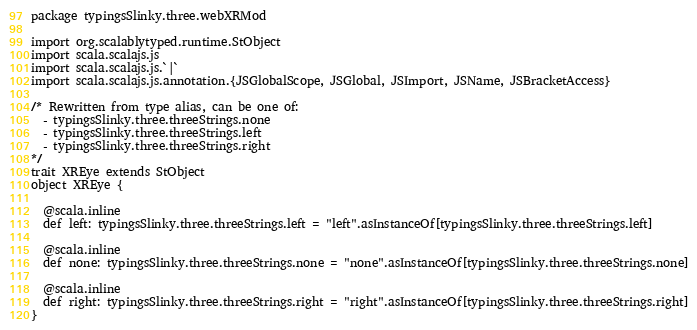Convert code to text. <code><loc_0><loc_0><loc_500><loc_500><_Scala_>package typingsSlinky.three.webXRMod

import org.scalablytyped.runtime.StObject
import scala.scalajs.js
import scala.scalajs.js.`|`
import scala.scalajs.js.annotation.{JSGlobalScope, JSGlobal, JSImport, JSName, JSBracketAccess}

/* Rewritten from type alias, can be one of: 
  - typingsSlinky.three.threeStrings.none
  - typingsSlinky.three.threeStrings.left
  - typingsSlinky.three.threeStrings.right
*/
trait XREye extends StObject
object XREye {
  
  @scala.inline
  def left: typingsSlinky.three.threeStrings.left = "left".asInstanceOf[typingsSlinky.three.threeStrings.left]
  
  @scala.inline
  def none: typingsSlinky.three.threeStrings.none = "none".asInstanceOf[typingsSlinky.three.threeStrings.none]
  
  @scala.inline
  def right: typingsSlinky.three.threeStrings.right = "right".asInstanceOf[typingsSlinky.three.threeStrings.right]
}
</code> 